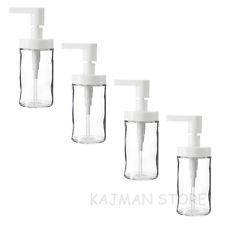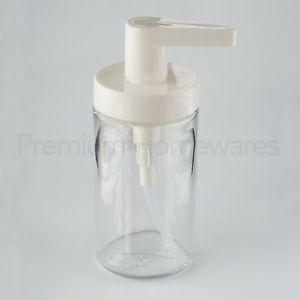The first image is the image on the left, the second image is the image on the right. Considering the images on both sides, is "Each image includes at least one clear glass cylinder with a white pump top, but the pump nozzles in the left and right images face opposite directions." valid? Answer yes or no. Yes. The first image is the image on the left, the second image is the image on the right. Analyze the images presented: Is the assertion "There are exactly two dispensers." valid? Answer yes or no. No. 